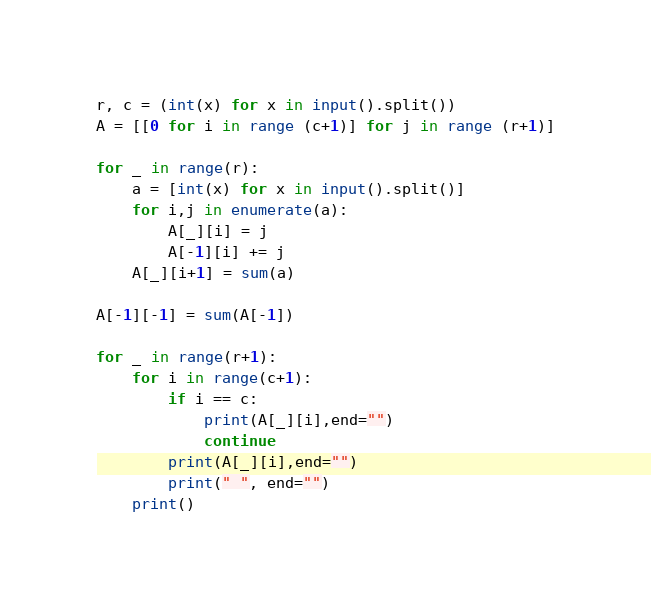<code> <loc_0><loc_0><loc_500><loc_500><_Python_>r, c = (int(x) for x in input().split())
A = [[0 for i in range (c+1)] for j in range (r+1)]

for _ in range(r):
    a = [int(x) for x in input().split()]
    for i,j in enumerate(a):
        A[_][i] = j
        A[-1][i] += j
    A[_][i+1] = sum(a)

A[-1][-1] = sum(A[-1])

for _ in range(r+1):
    for i in range(c+1):
        if i == c:
            print(A[_][i],end="")
            continue
        print(A[_][i],end="")
        print(" ", end="")
    print()    
</code> 